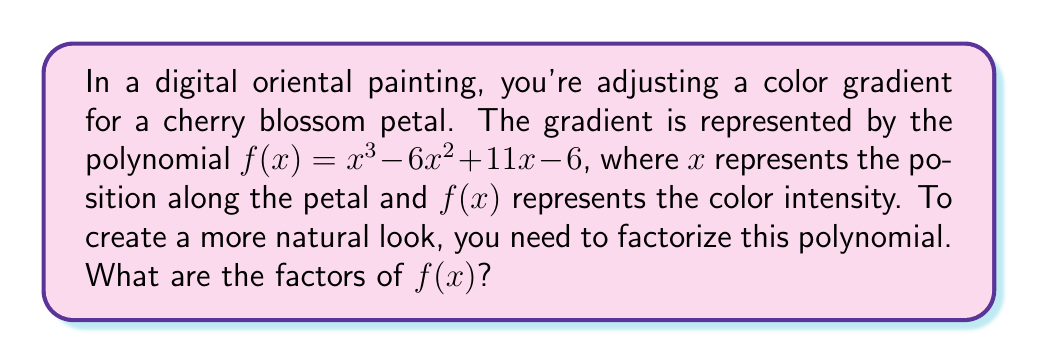Teach me how to tackle this problem. Let's approach this step-by-step:

1) First, we can try to find a factor by guessing a root. Since the constant term is -6, possible factors are ±1, ±2, ±3, ±6.

2) Testing $x = 1$:
   $f(1) = 1^3 - 6(1)^2 + 11(1) - 6 = 1 - 6 + 11 - 6 = 0$
   
   So, $(x - 1)$ is a factor.

3) We can use polynomial long division to divide $f(x)$ by $(x - 1)$:

   $$\frac{x^3 - 6x^2 + 11x - 6}{x - 1} = x^2 - 5x + 6$$

4) Now we have: $f(x) = (x - 1)(x^2 - 5x + 6)$

5) We can factor the quadratic term $x^2 - 5x + 6$:
   
   It factors as $(x - 2)(x - 3)$

6) Therefore, the complete factorization is:

   $f(x) = (x - 1)(x - 2)(x - 3)$

This factorization will allow for more precise control over the color gradient, as each factor represents a specific point of change in the petal's coloration.
Answer: $(x - 1)(x - 2)(x - 3)$ 